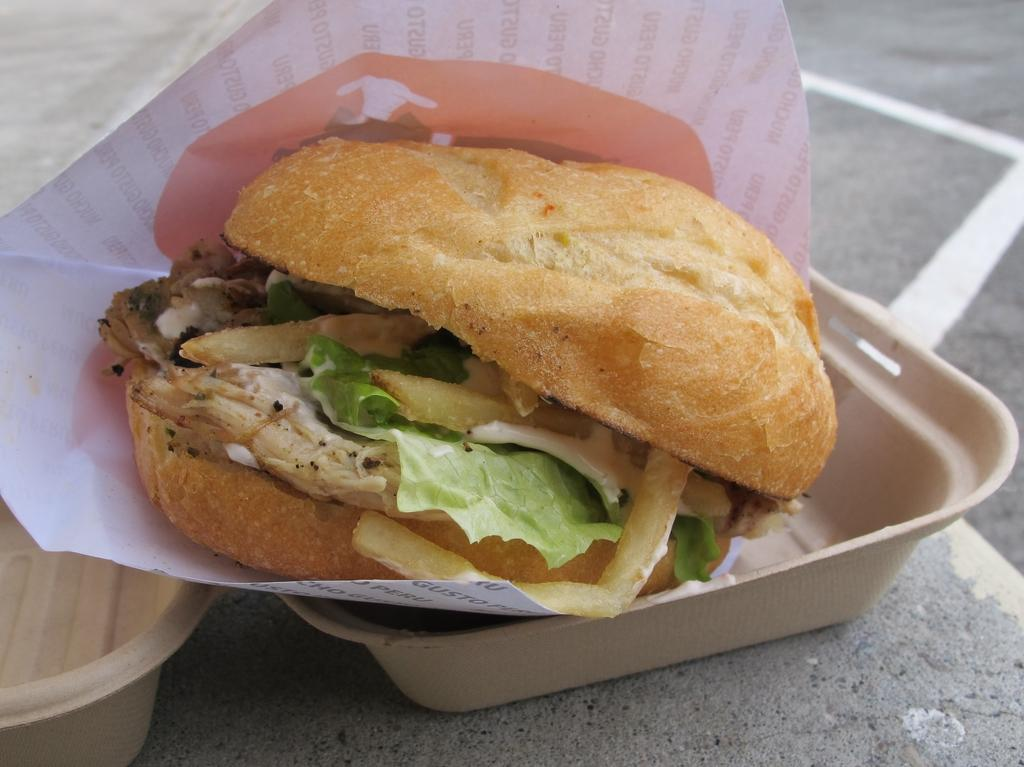What objects are present in the image that are typically used for serving or eating food? There are plates in the image. What else can be seen in the image besides plates? There is food and paper visible in the image. What is the opinion of the ducks about the food in the image? There are no ducks present in the image, so it is not possible to determine their opinion about the food. Are there any dinosaurs visible in the image? There are no dinosaurs present in the image. 